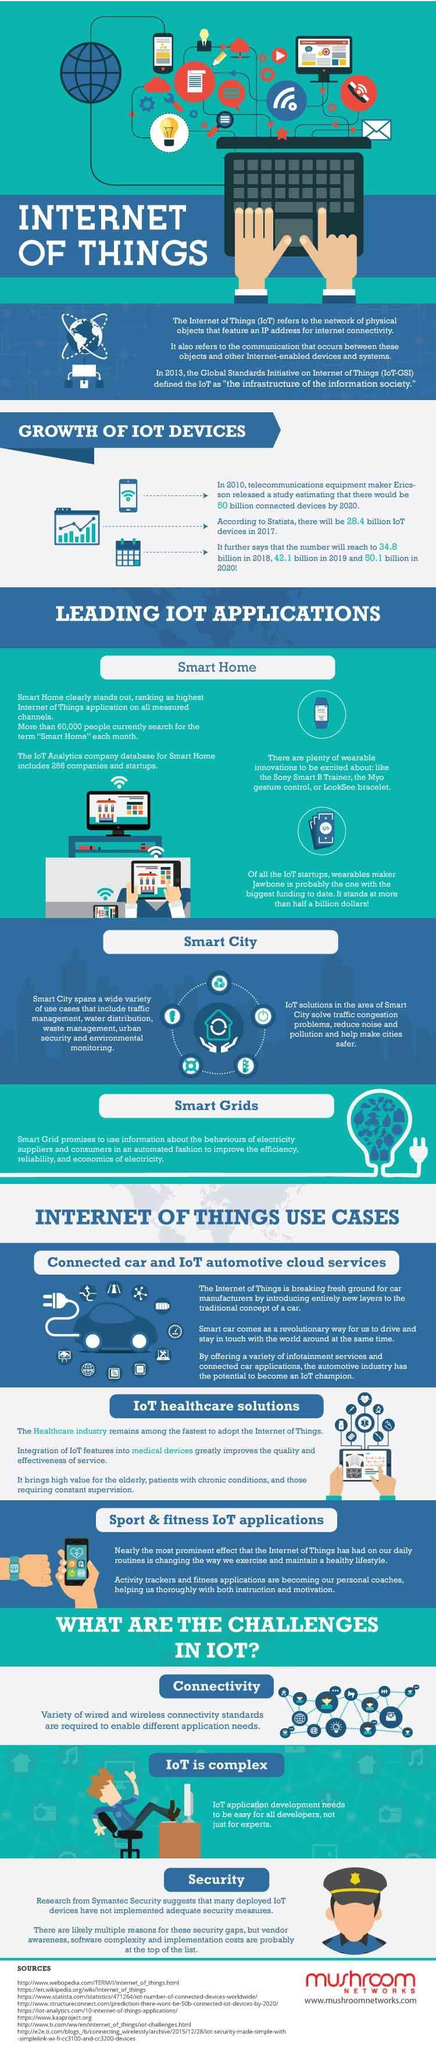what will be the increase in billions in IoT devices from 2017 to 2018
Answer the question with a short phrase. 6.4 what will be the increase in billions in IoT devices from 2019 to 2020 8 WHat are the leading IOT Applications Smart Home, Smart City, Smart Grids which are the 3 main IoT Use cases Connected car and IoT automative cloud services, IoT healthcare solutions, Sport & fitness IoT applications WHat all can be solved using IoT solutions in Smart City traffic congestion problems, reduce noise and pollution and help make cities safer what are the 3 main challenges in IoT Connectivity, IoT is complex, Security 